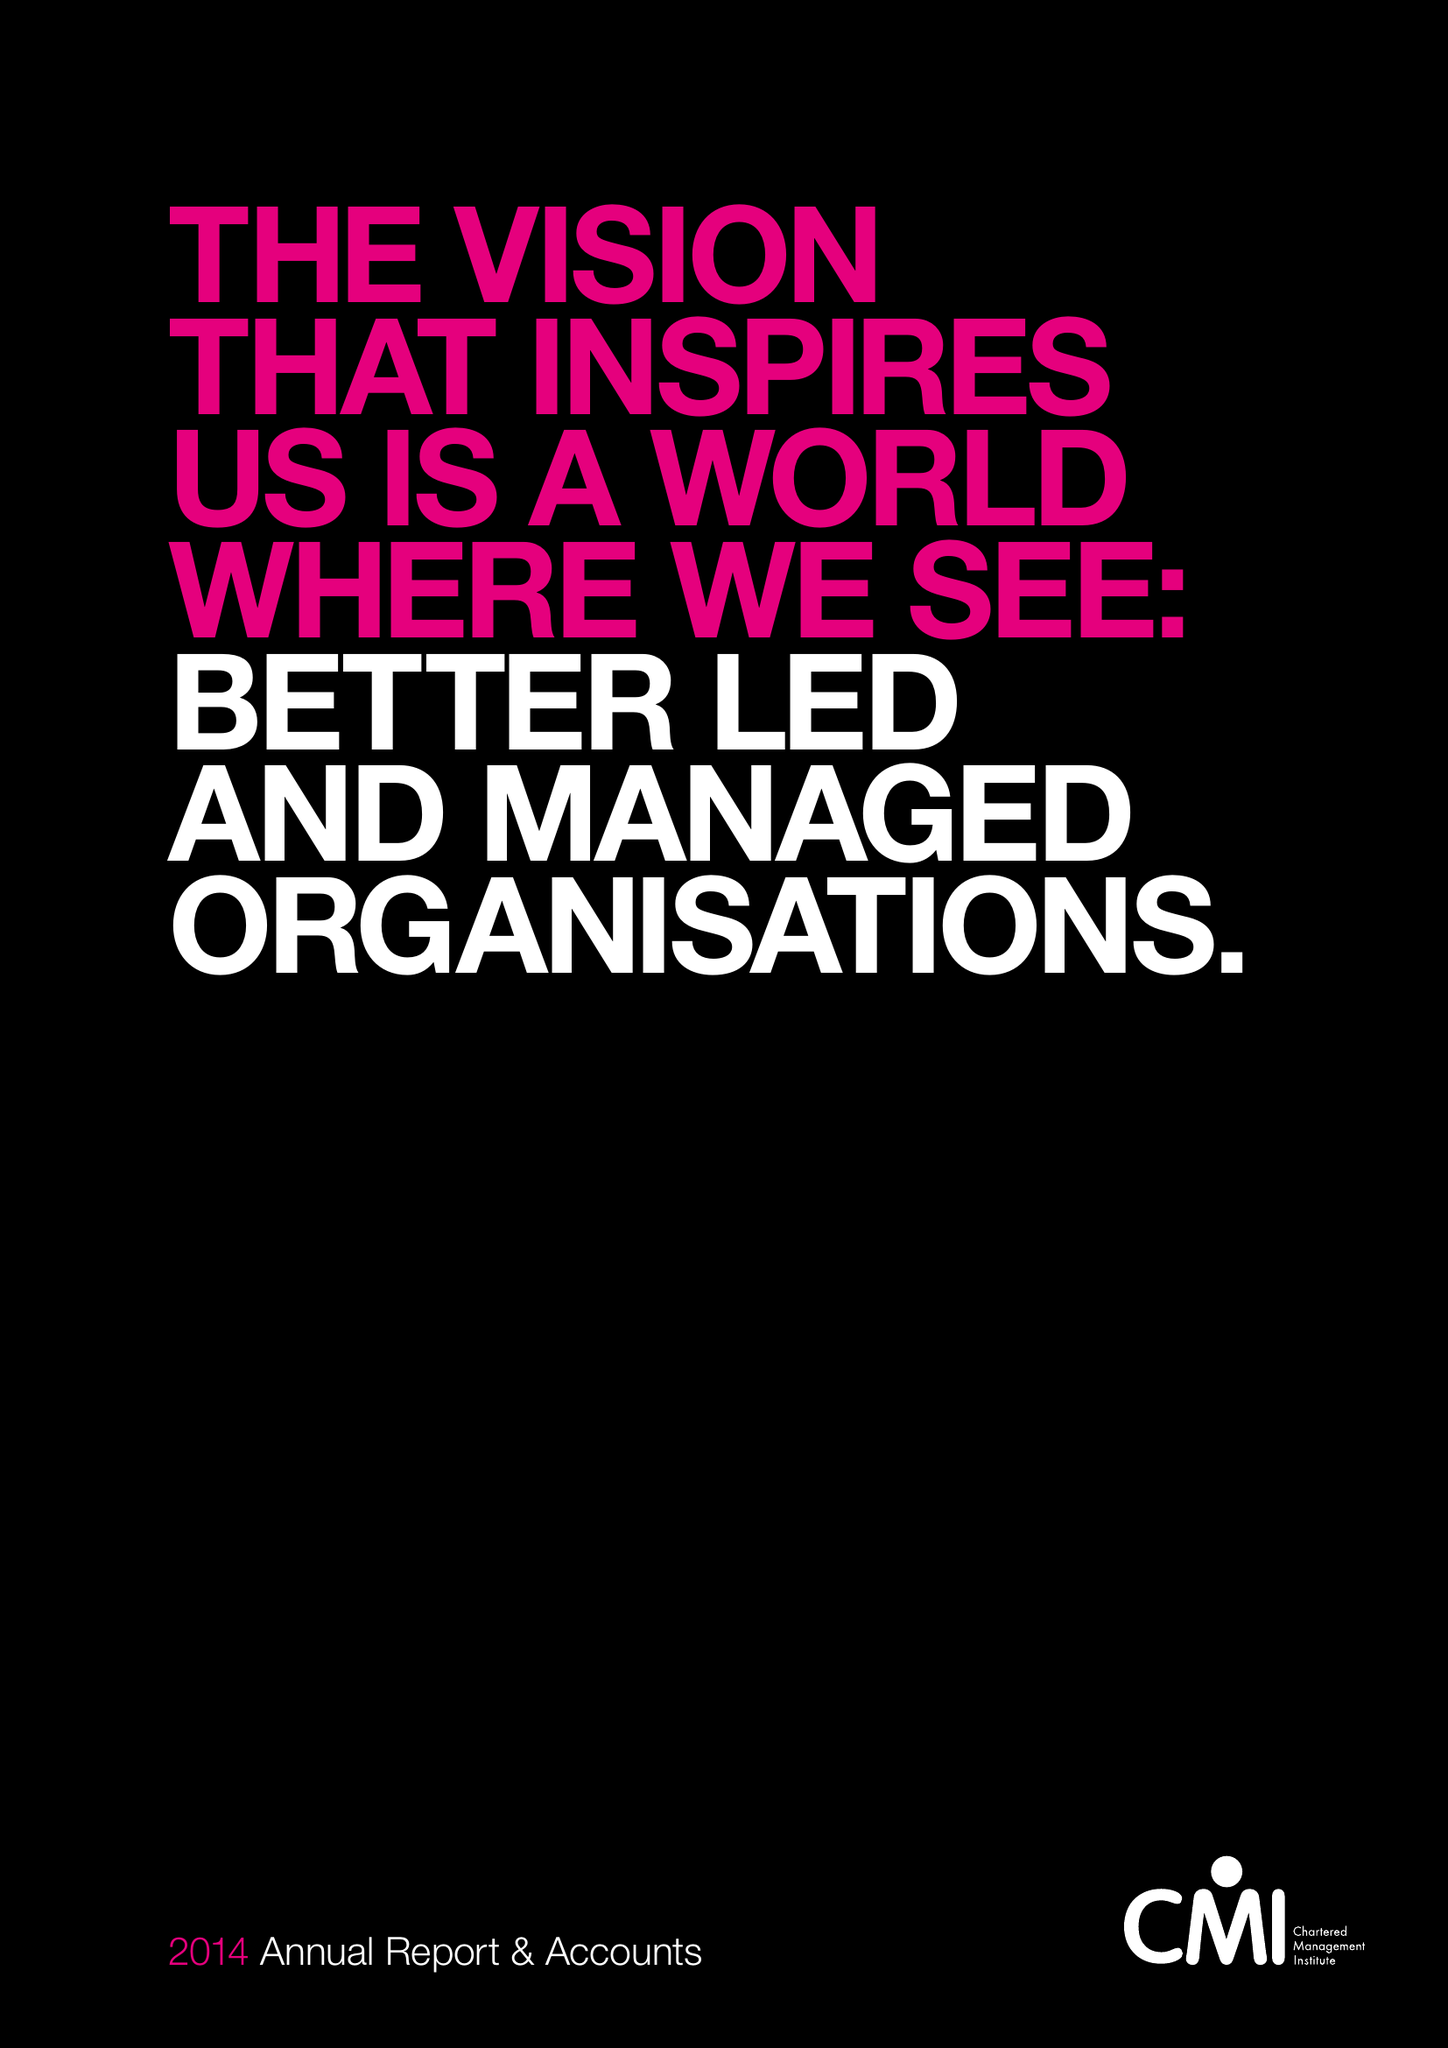What is the value for the spending_annually_in_british_pounds?
Answer the question using a single word or phrase. 9967000.00 